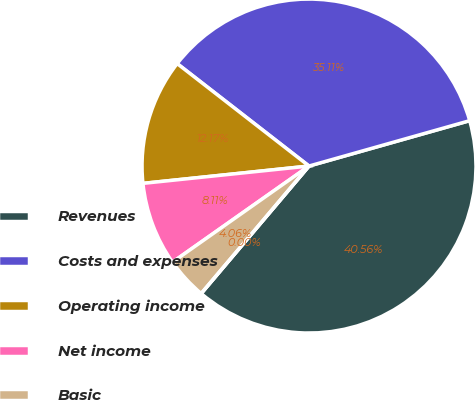Convert chart to OTSL. <chart><loc_0><loc_0><loc_500><loc_500><pie_chart><fcel>Revenues<fcel>Costs and expenses<fcel>Operating income<fcel>Net income<fcel>Basic<fcel>Diluted<nl><fcel>40.56%<fcel>35.11%<fcel>12.17%<fcel>8.11%<fcel>4.06%<fcel>0.0%<nl></chart> 